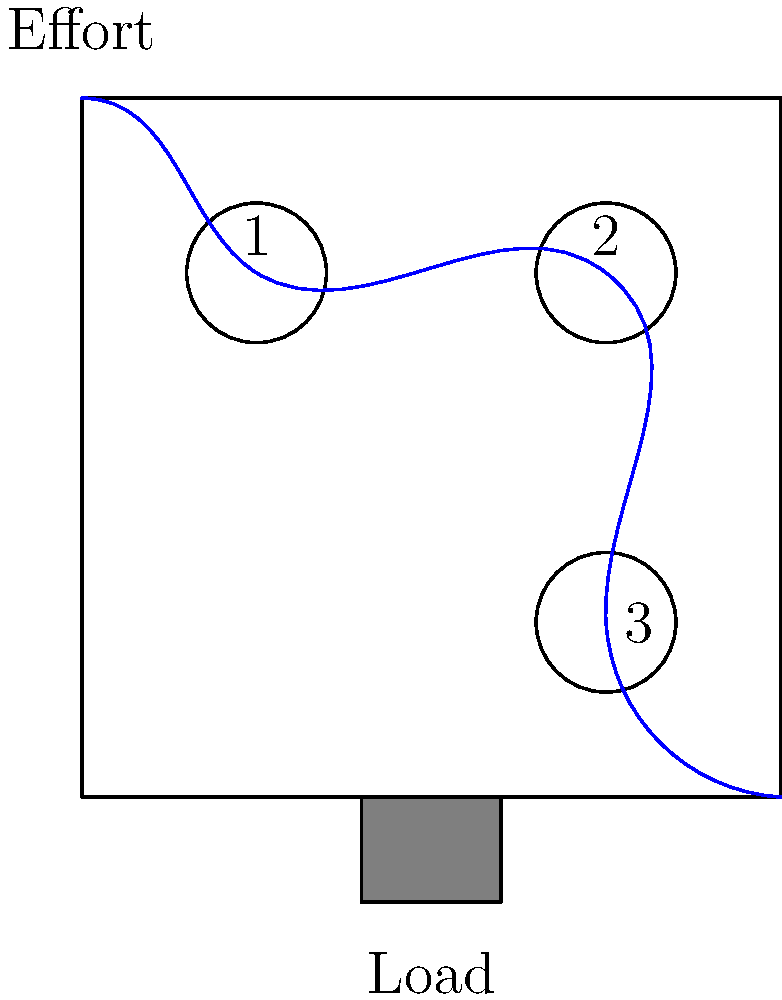In a commodities trading warehouse, a pulley system is used to load heavy cargo. The system consists of three pulleys as shown in the diagram. If the load weighs 600 kg, what is the minimum effort required to lift it, assuming the system is frictionless? Express your answer in Newtons (N), rounded to the nearest whole number. To solve this problem, we need to follow these steps:

1. Determine the mechanical advantage of the pulley system:
   - Each pulley in the system reduces the effort by half
   - With 3 pulleys, the mechanical advantage is $2^3 = 8$

2. Calculate the weight of the load in Newtons:
   - Weight = mass × acceleration due to gravity
   - $W = 600 \text{ kg} \times 9.8 \text{ m/s}^2 = 5880 \text{ N}$

3. Calculate the minimum effort required:
   - Effort = Weight ÷ Mechanical Advantage
   - $E = 5880 \text{ N} \div 8 = 735 \text{ N}$

4. Round the result to the nearest whole number:
   - 735 N rounds to 735 N

Therefore, the minimum effort required to lift the 600 kg load is 735 N.
Answer: 735 N 